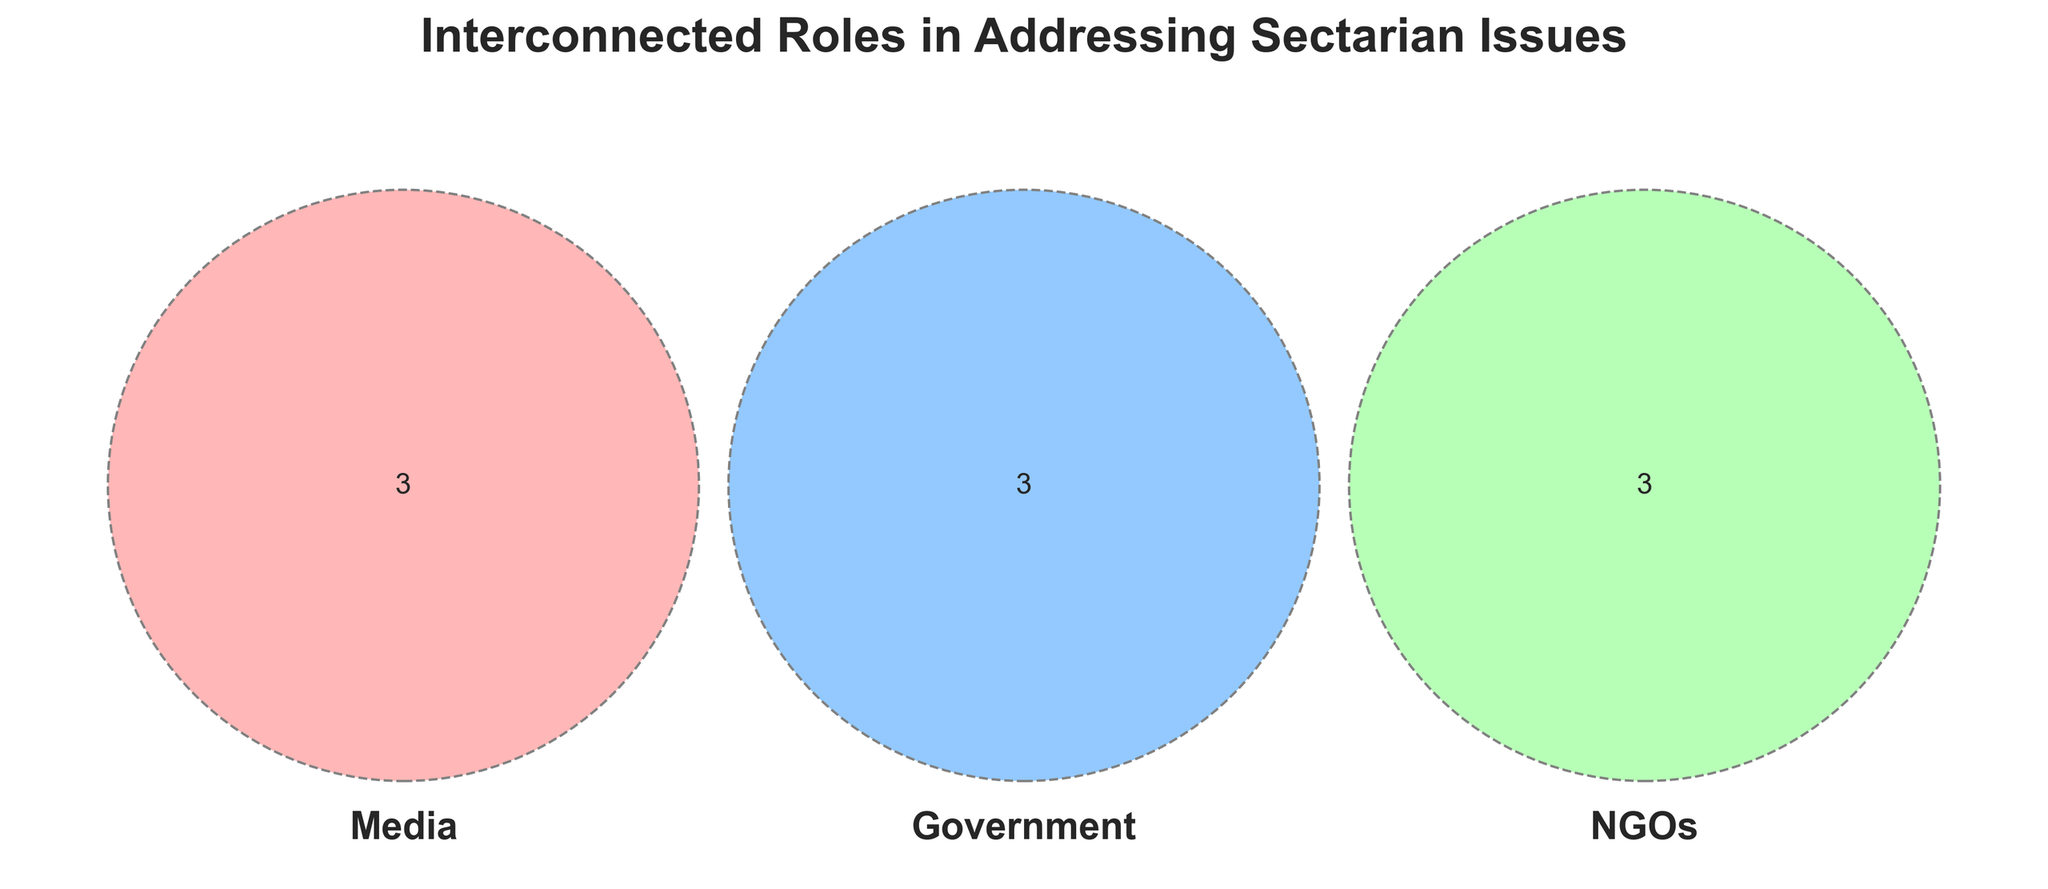What is the title of the Venn Diagram? The title of the Venn Diagram is prominently displayed at the top of the figure in a larger and bold font.
Answer: Interconnected Roles in Addressing Sectarian Issues How many sections are there in the Venn Diagram? A Venn Diagram with three sets typically contains seven sections: three individual, three shared by pairs, and one shared by all three.
Answer: 7 Which category is dedicated to 'policy making'? By examining the segments labeled for each category, 'policy making' is found within the Government circle.
Answer: Government How many elements are exclusively found in the Media category? Focus on the Media circle to identify elements that do not intersect with Government or NGOs.
Answer: 3 Which category includes 'peacebuilding initiatives'? 'Peacebuilding initiatives' is found exclusively within the NGOs set.
Answer: NGOs What three roles are shared between Media and NGOs but not Government? Identify the section where Media and NGOs intersect but do not include the Government circle.
Answer: Public awareness, Information dissemination, Social media influence Name one element that all three categories (Media, Government, NGOs) do not share. Any element from the sections where only one or two sets intersect, excluding the center where all three overlap.
Answer: BBC (for Media), United Nations (for Government), Amnesty International (for NGOs) [Any one is correct] Is 'diplomatic negotiations' exclusive to any category? Which one? By locating 'diplomatic negotiations' within the diagram, it falls within the Government category alone.
Answer: Yes, Government What role is common between Media and Government? Locate the section where Media and Government overlap, and the role listed there is 'Investigative reporting'.
Answer: Investigative reporting Which organization fits into all three categories of Media, Government, and NGOs? Identify the center of the Venn Diagram where all three sets overlap, noting the shared organization.
Answer: There isn't any organization listed in the shared section 